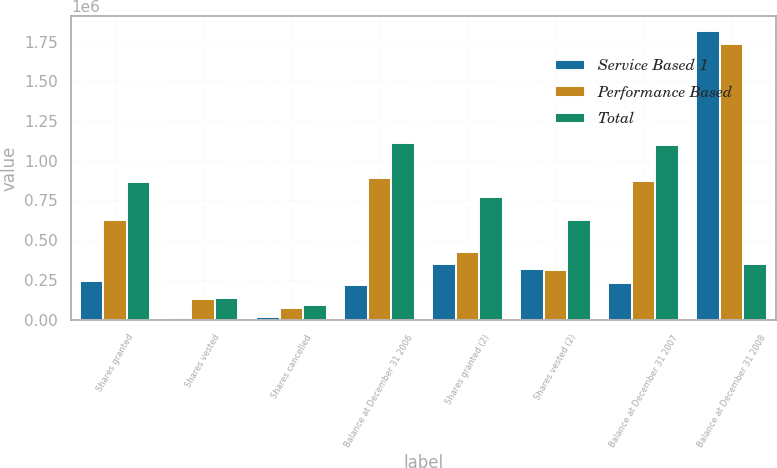Convert chart. <chart><loc_0><loc_0><loc_500><loc_500><stacked_bar_chart><ecel><fcel>Shares granted<fcel>Shares vested<fcel>Shares cancelled<fcel>Balance at December 31 2006<fcel>Shares granted (2)<fcel>Shares vested (2)<fcel>Balance at December 31 2007<fcel>Balance at December 31 2008<nl><fcel>Service Based 1<fcel>242015<fcel>8100<fcel>14460<fcel>219455<fcel>350809<fcel>318864<fcel>228576<fcel>1.81719e+06<nl><fcel>Performance Based<fcel>626672<fcel>130793<fcel>75765<fcel>889954<fcel>422980<fcel>311033<fcel>872558<fcel>1.7367e+06<nl><fcel>Total<fcel>868687<fcel>138893<fcel>90225<fcel>1.10941e+06<fcel>773789<fcel>629897<fcel>1.10113e+06<fcel>350809<nl></chart> 